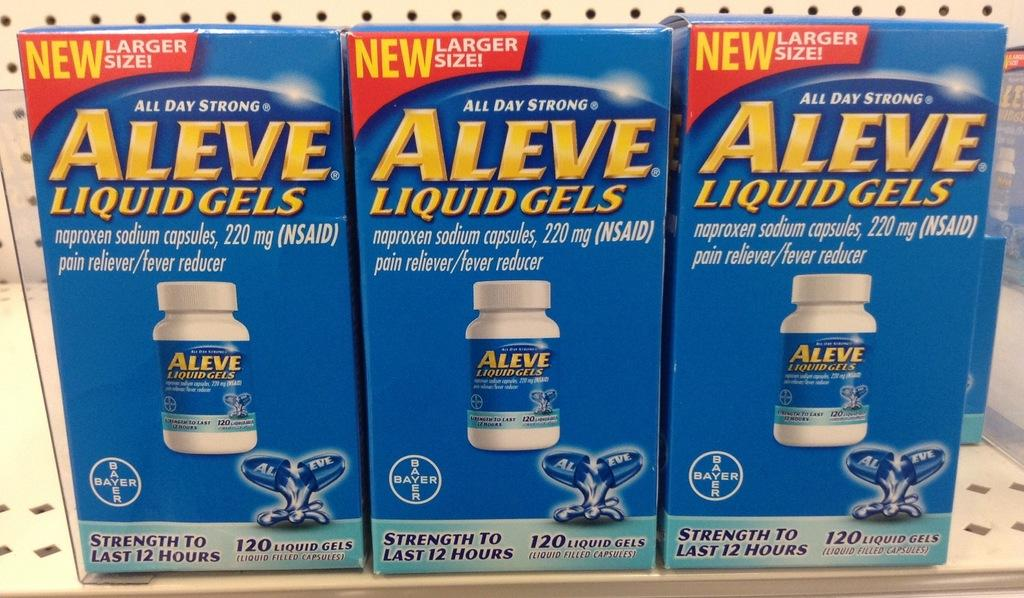<image>
Write a terse but informative summary of the picture. Several bottles of Aleve liquid gels on a store shelf. 